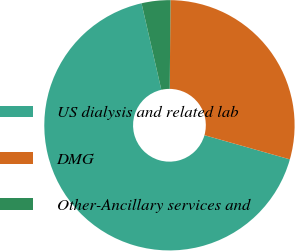Convert chart to OTSL. <chart><loc_0><loc_0><loc_500><loc_500><pie_chart><fcel>US dialysis and related lab<fcel>DMG<fcel>Other-Ancillary services and<nl><fcel>67.03%<fcel>29.26%<fcel>3.71%<nl></chart> 